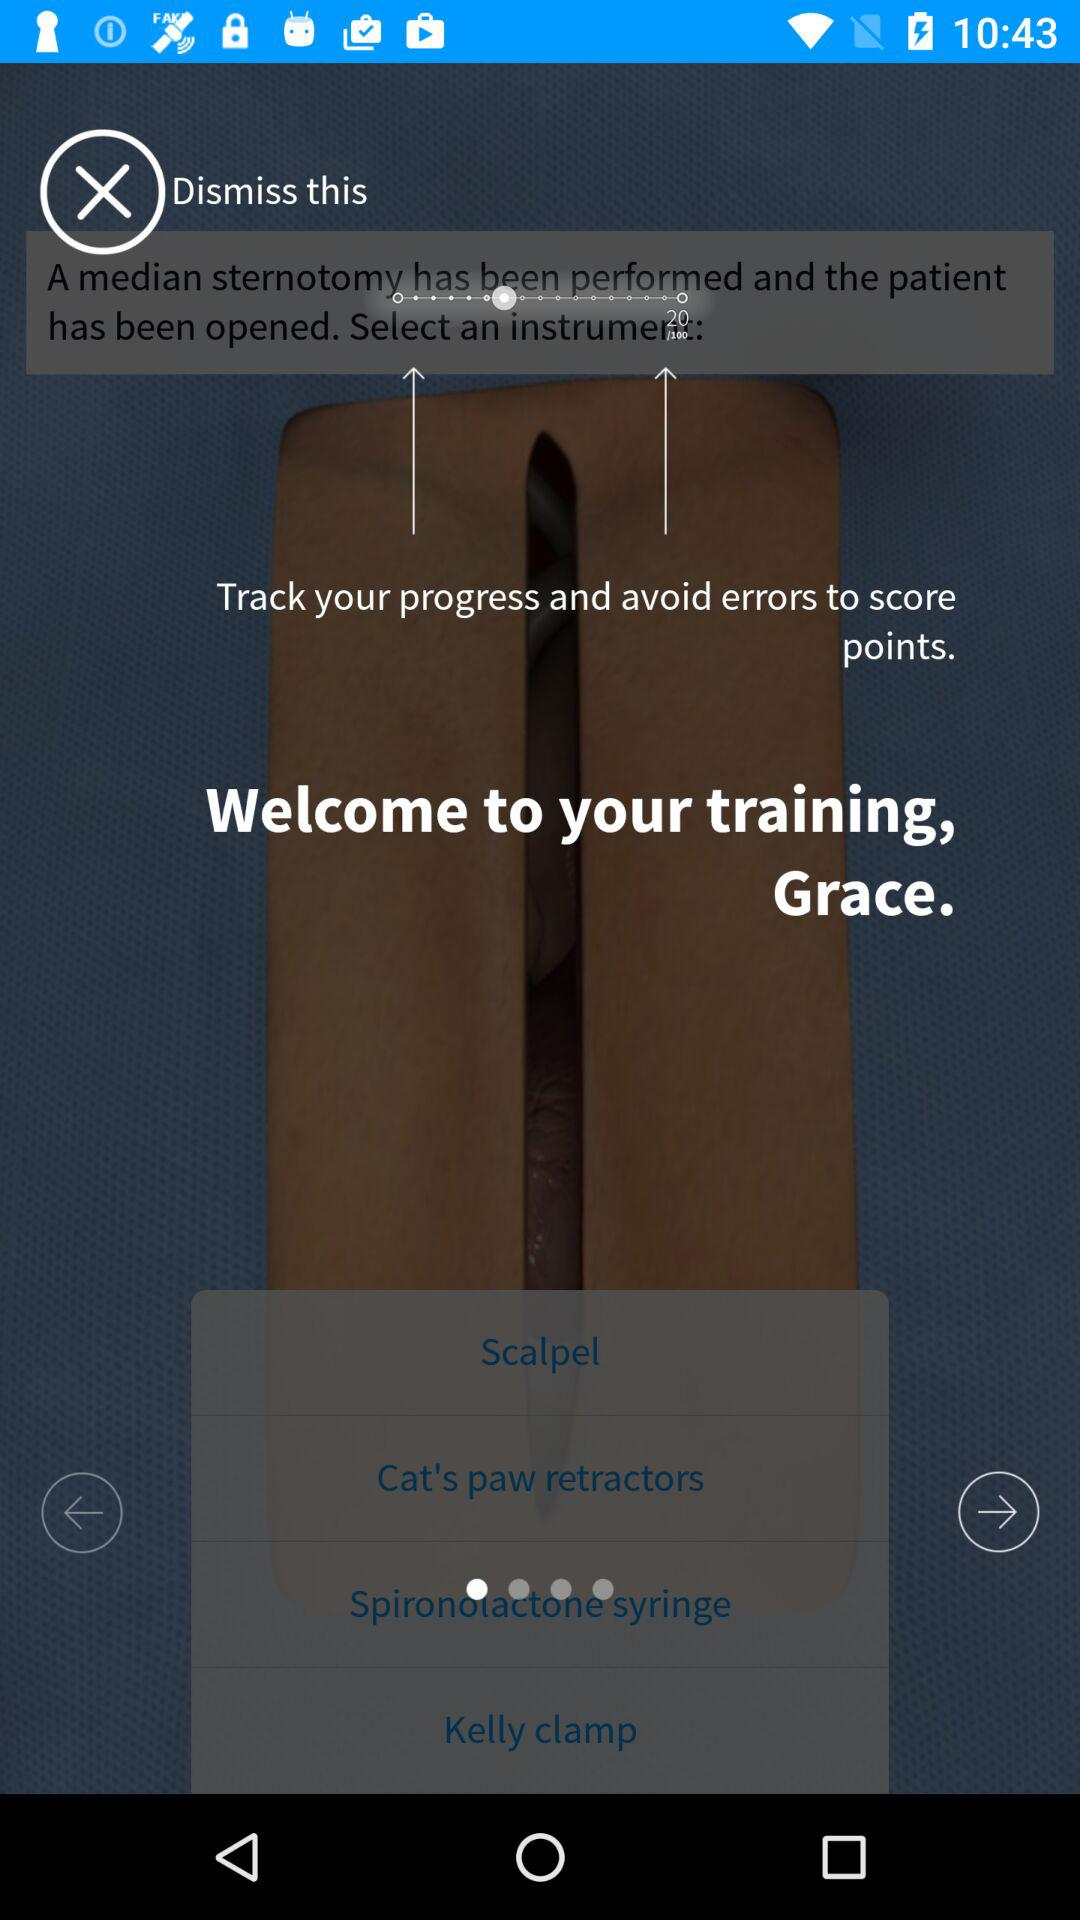What is the user name? The user name is Grace. 